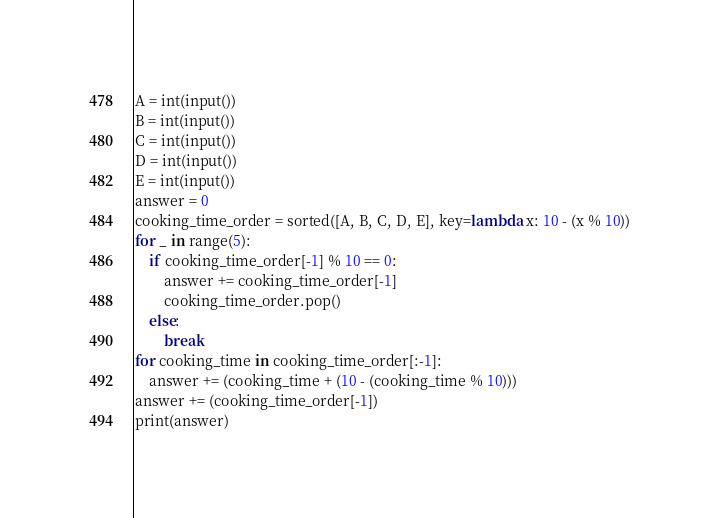Convert code to text. <code><loc_0><loc_0><loc_500><loc_500><_Python_>A = int(input())
B = int(input())
C = int(input())
D = int(input())
E = int(input())
answer = 0
cooking_time_order = sorted([A, B, C, D, E], key=lambda x: 10 - (x % 10))
for _ in range(5):
    if cooking_time_order[-1] % 10 == 0:
        answer += cooking_time_order[-1]
        cooking_time_order.pop()
    else:
        break
for cooking_time in cooking_time_order[:-1]:
    answer += (cooking_time + (10 - (cooking_time % 10)))
answer += (cooking_time_order[-1])
print(answer)
</code> 